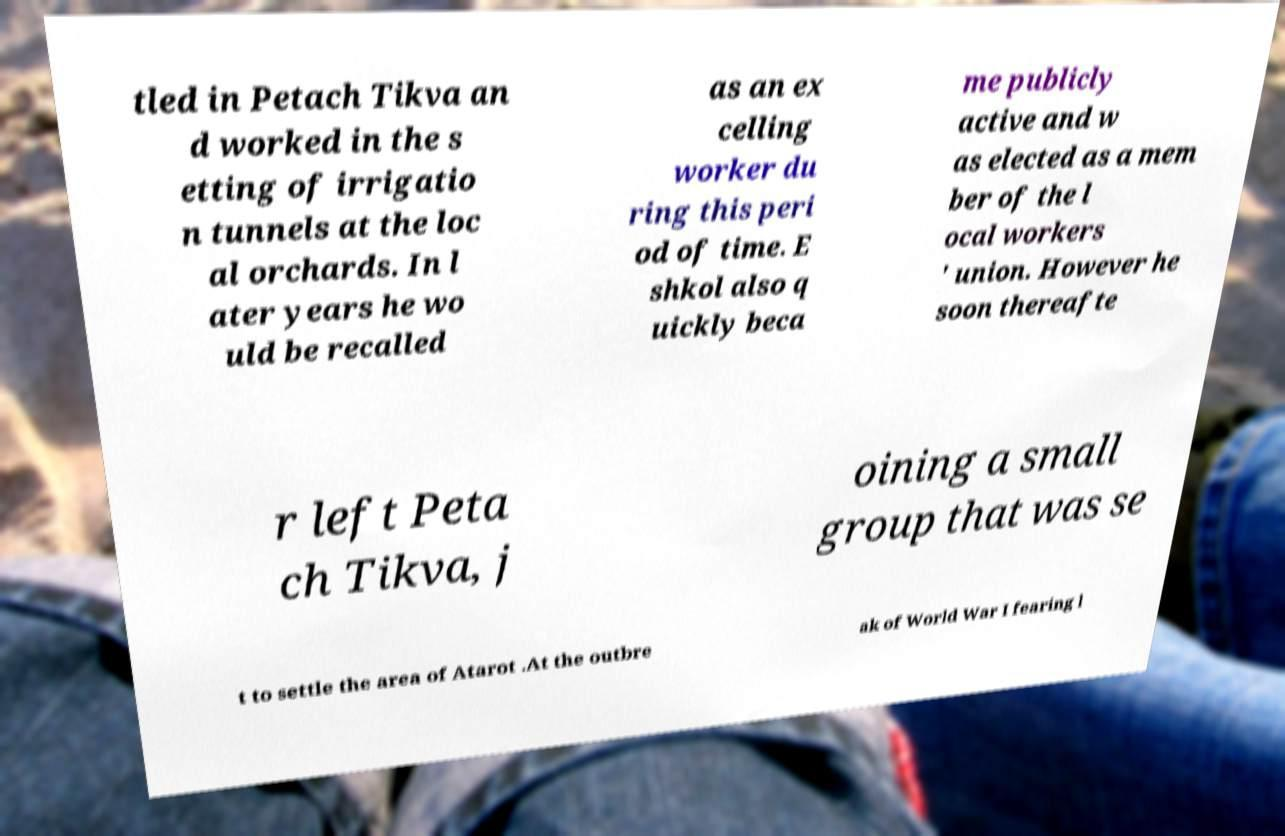Could you extract and type out the text from this image? tled in Petach Tikva an d worked in the s etting of irrigatio n tunnels at the loc al orchards. In l ater years he wo uld be recalled as an ex celling worker du ring this peri od of time. E shkol also q uickly beca me publicly active and w as elected as a mem ber of the l ocal workers ' union. However he soon thereafte r left Peta ch Tikva, j oining a small group that was se t to settle the area of Atarot .At the outbre ak of World War I fearing l 